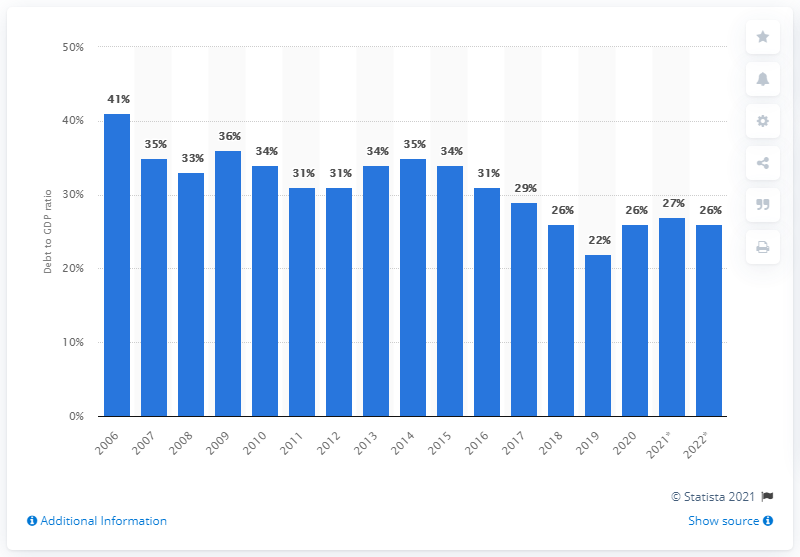Give some essential details in this illustration. The lowest GDP ratio measured in 2019 was 22%. In 2020, Sweden's GDP ratio was 26 percent. In 2014, the ratio of the Swedish central government debt to gross domestic product decreased. 